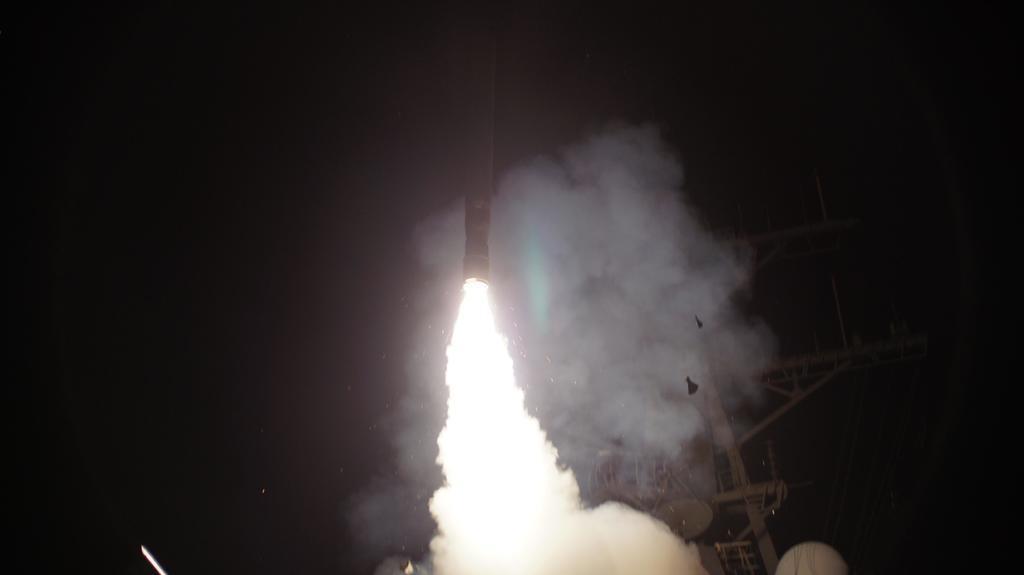Can you describe this image briefly? In this image it looks like a rocket with fire. And at the side there is an object. And there is a rod. 